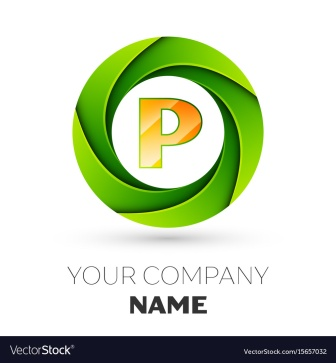What types of industries do you think would benefit from using a logo like this? A logo with this design would be particularly effective for companies in the technology sector, creative industries, or startups that prioritize innovation and modernity. Its dynamic and modern aesthetic could also appeal to businesses in marketing, advertising, and any field that values bold and forward-thinking ideas. The freshness of the green paired with the energetic orange could also work well for health and wellness brands. 